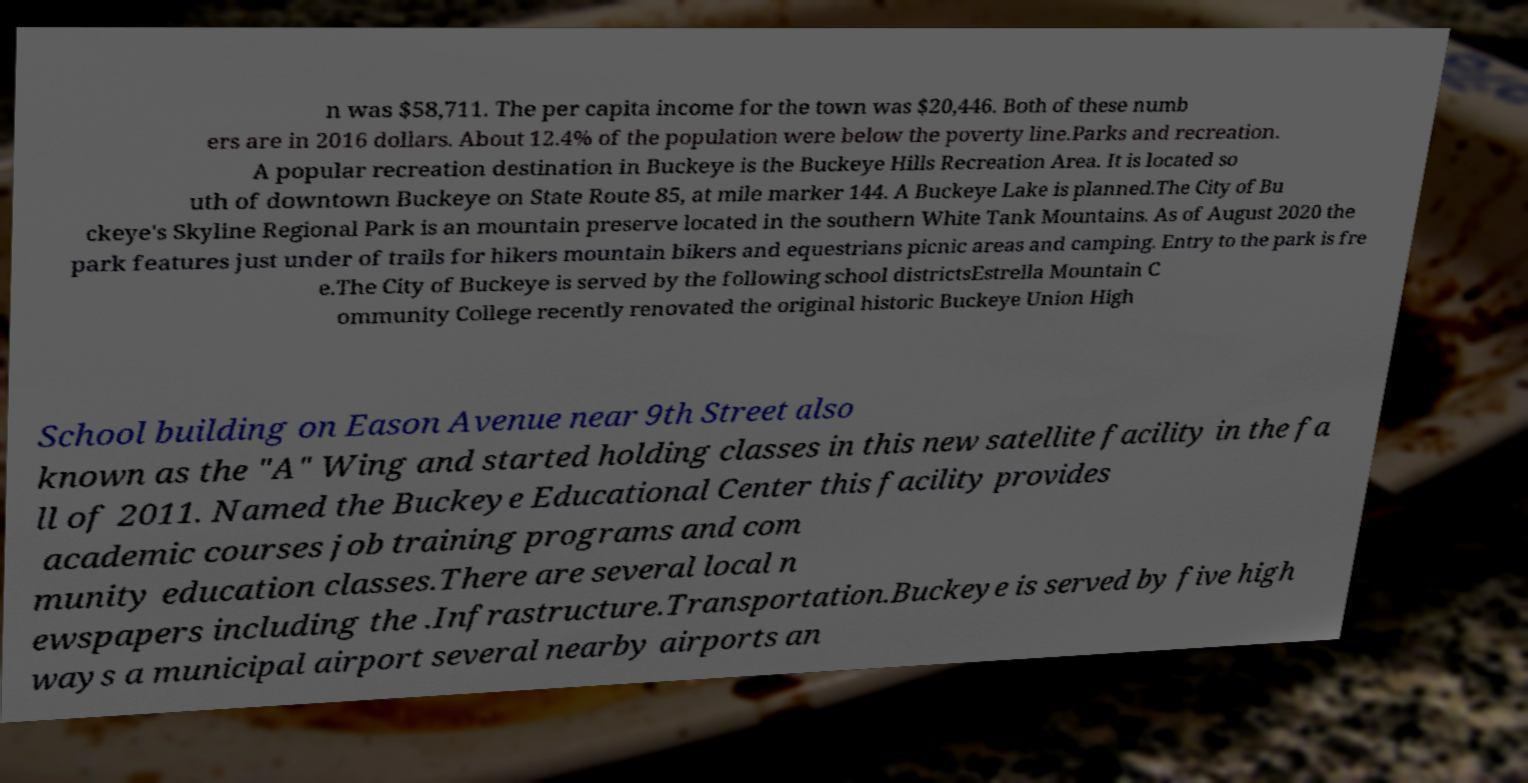Please read and relay the text visible in this image. What does it say? n was $58,711. The per capita income for the town was $20,446. Both of these numb ers are in 2016 dollars. About 12.4% of the population were below the poverty line.Parks and recreation. A popular recreation destination in Buckeye is the Buckeye Hills Recreation Area. It is located so uth of downtown Buckeye on State Route 85, at mile marker 144. A Buckeye Lake is planned.The City of Bu ckeye's Skyline Regional Park is an mountain preserve located in the southern White Tank Mountains. As of August 2020 the park features just under of trails for hikers mountain bikers and equestrians picnic areas and camping. Entry to the park is fre e.The City of Buckeye is served by the following school districtsEstrella Mountain C ommunity College recently renovated the original historic Buckeye Union High School building on Eason Avenue near 9th Street also known as the "A" Wing and started holding classes in this new satellite facility in the fa ll of 2011. Named the Buckeye Educational Center this facility provides academic courses job training programs and com munity education classes.There are several local n ewspapers including the .Infrastructure.Transportation.Buckeye is served by five high ways a municipal airport several nearby airports an 